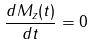<formula> <loc_0><loc_0><loc_500><loc_500>\frac { d M _ { z } ( t ) } { d t } = 0</formula> 